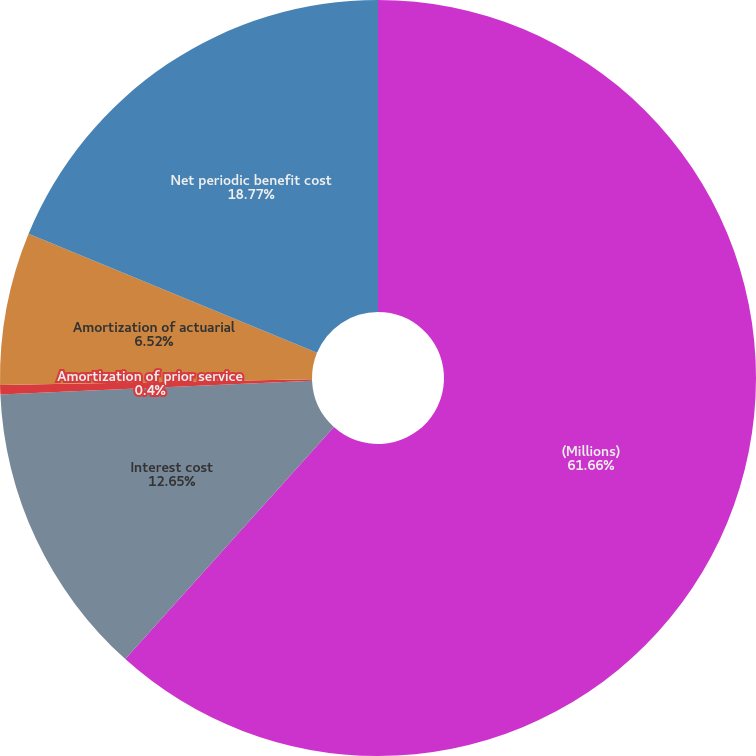Convert chart to OTSL. <chart><loc_0><loc_0><loc_500><loc_500><pie_chart><fcel>(Millions)<fcel>Interest cost<fcel>Amortization of prior service<fcel>Amortization of actuarial<fcel>Net periodic benefit cost<nl><fcel>61.65%<fcel>12.65%<fcel>0.4%<fcel>6.52%<fcel>18.77%<nl></chart> 